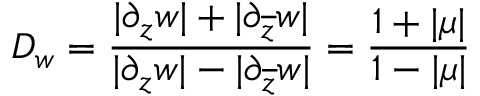Convert formula to latex. <formula><loc_0><loc_0><loc_500><loc_500>D _ { w } = \frac { | \partial _ { z } w | + | \partial _ { \overline { z } } w | } { | \partial _ { z } w | - | \partial _ { \overline { z } } w | } = \frac { 1 + | \mu | } { 1 - | \mu | }</formula> 